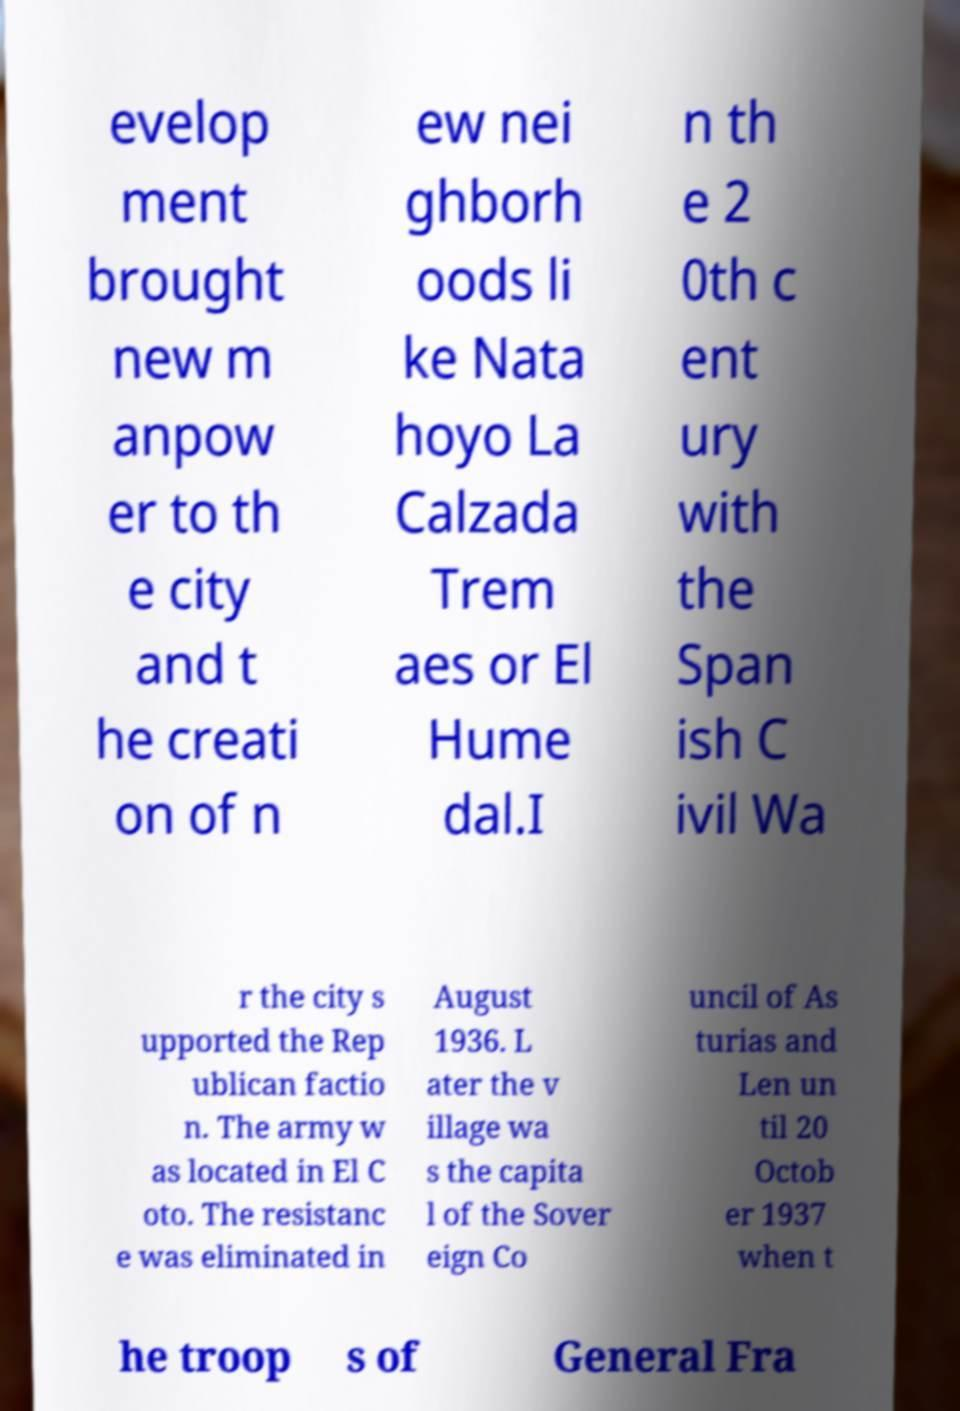Can you accurately transcribe the text from the provided image for me? evelop ment brought new m anpow er to th e city and t he creati on of n ew nei ghborh oods li ke Nata hoyo La Calzada Trem aes or El Hume dal.I n th e 2 0th c ent ury with the Span ish C ivil Wa r the city s upported the Rep ublican factio n. The army w as located in El C oto. The resistanc e was eliminated in August 1936. L ater the v illage wa s the capita l of the Sover eign Co uncil of As turias and Len un til 20 Octob er 1937 when t he troop s of General Fra 